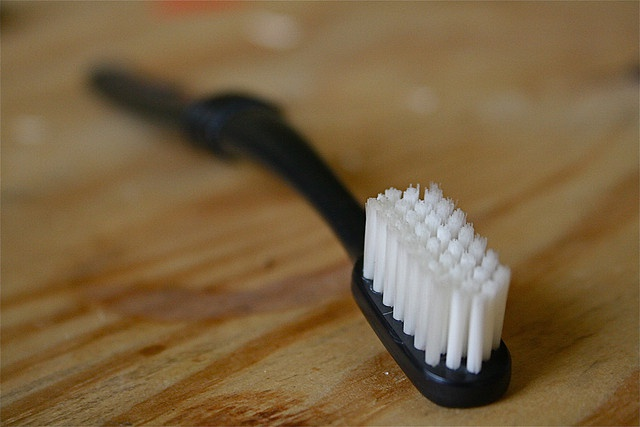Describe the objects in this image and their specific colors. I can see a toothbrush in gray, black, darkgray, and lightgray tones in this image. 